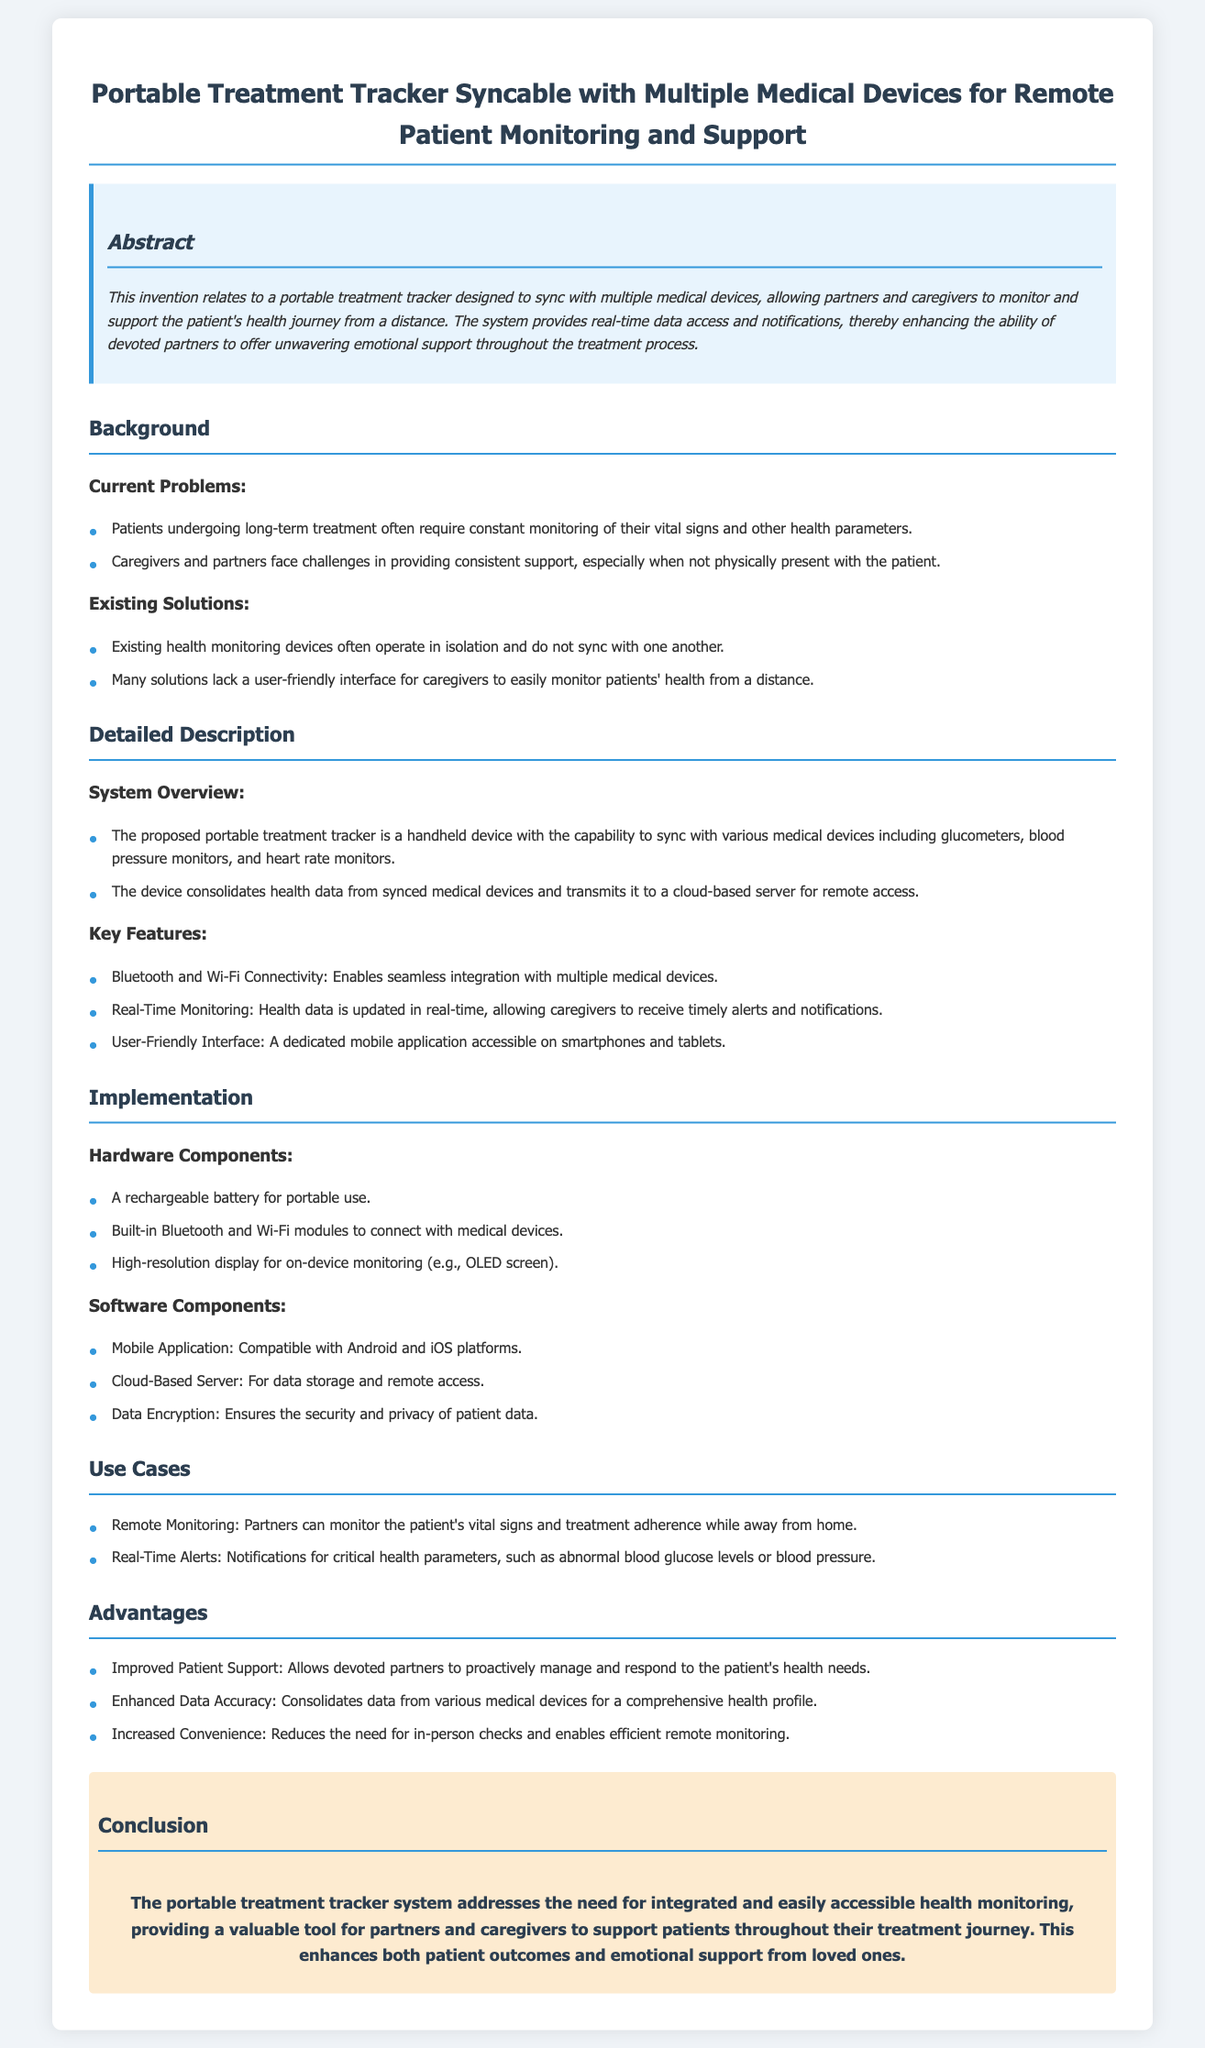What is the title of the patent application? The title of the patent application describes the invention being proposed and is found at the top of the document.
Answer: Portable Treatment Tracker Syncable with Multiple Medical Devices for Remote Patient Monitoring and Support What are the key components of the hardware? The hardware components are specified in the section detailing implementation and include different elements relevant to the device.
Answer: Rechargeable battery, Bluetooth and Wi-Fi modules, high-resolution display How does the portable treatment tracker enhance patient support? The advantages section explains how the device improves patient support through specific features that help caregivers.
Answer: Allows devoted partners to proactively manage and respond to the patient's health needs What feature allows for seamless integration with medical devices? The key features provide specific capabilities of the device, including connectivity options established for this purpose.
Answer: Bluetooth and Wi-Fi Connectivity What is the primary purpose of the portable treatment tracker? The abstract succinctly presents the main goal and functionality of the invention within the document.
Answer: Monitor and support the patient's health journey from a distance How does the system ensure the security of patient data? The software components section mentions specific measures taken to protect sensitive information in the system.
Answer: Data Encryption 